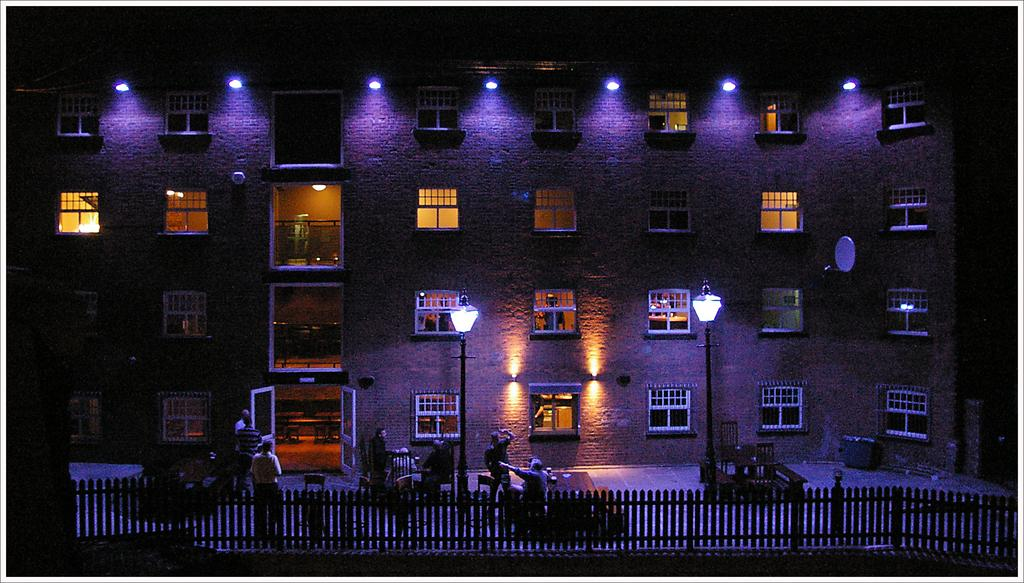What is the main feature in the image? There is a rail in the image. Are there any people present in the image? Yes, there are people in the image. What type of structure can be seen in the image? There is a building with windows in the image. What can be seen at the top of the image? There are lights visible at the top of the image. Is there steam coming out of the volcano in the image? There is no volcano present in the image, so there cannot be any steam coming out of it. 